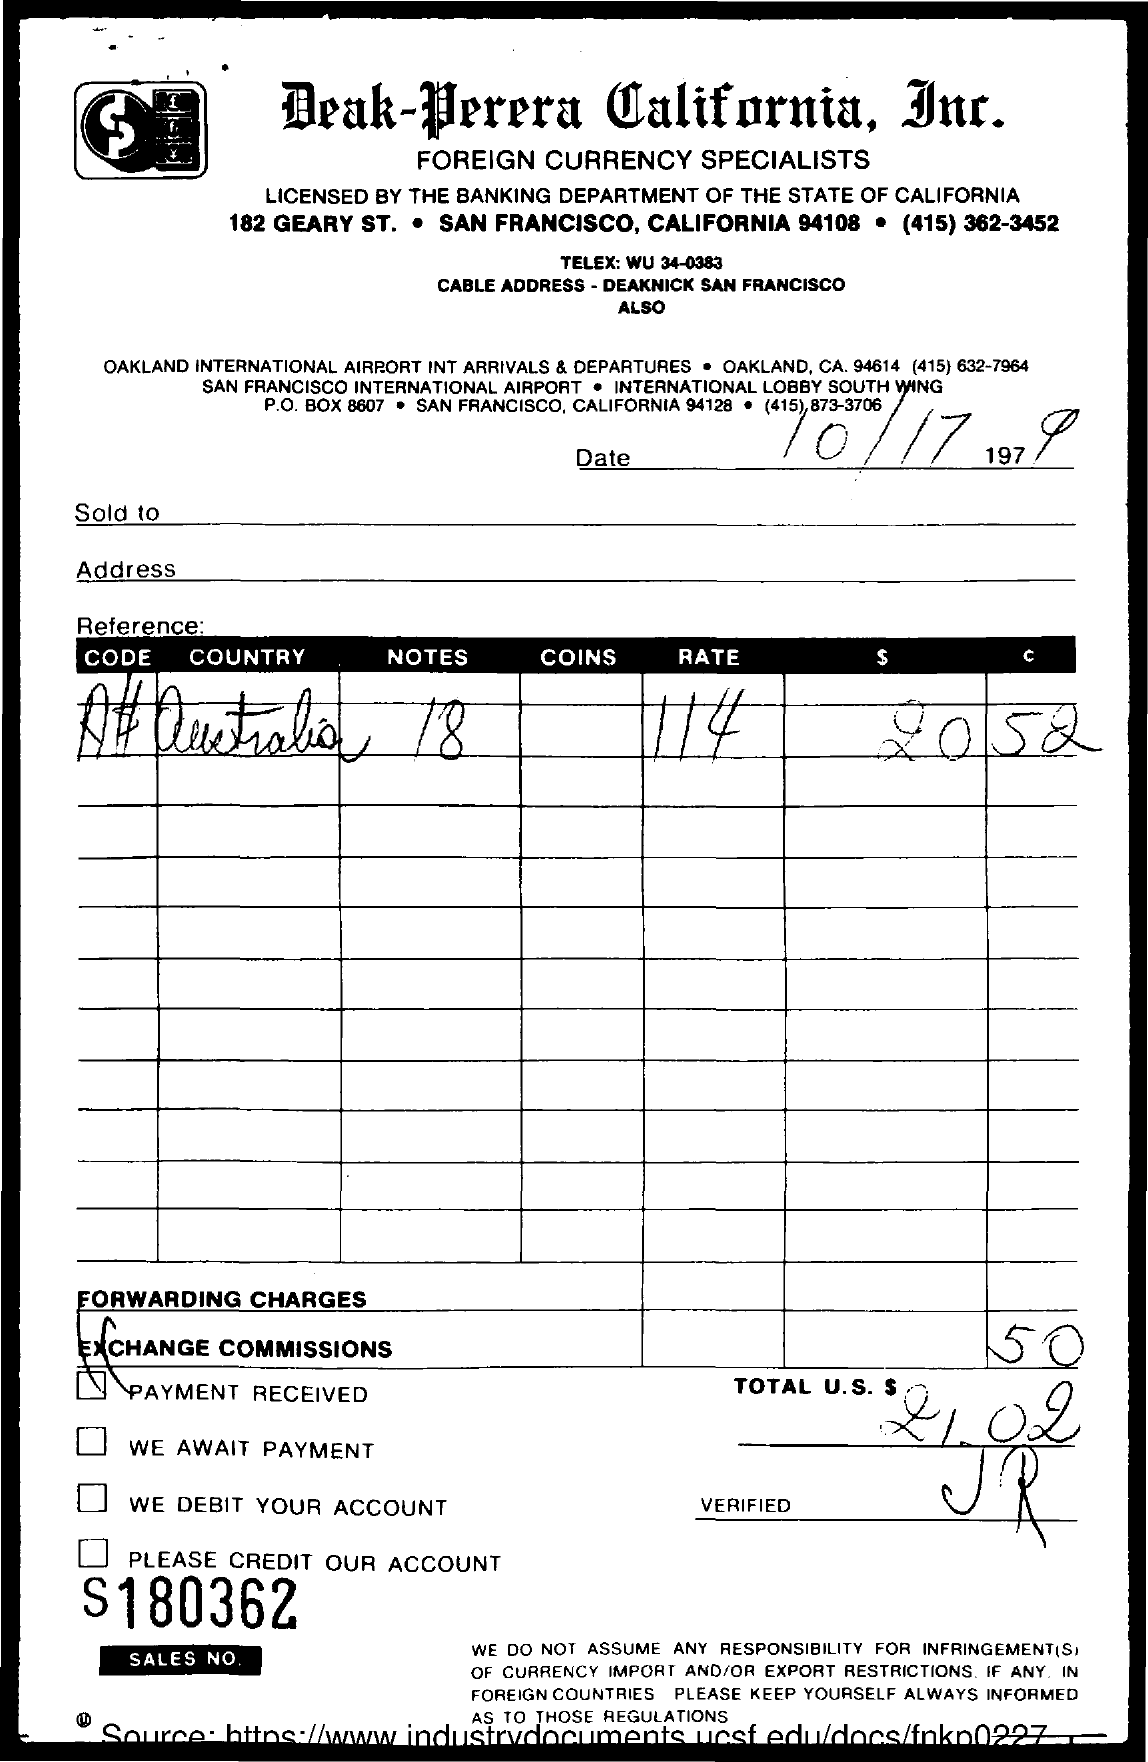Indicate a few pertinent items in this graphic. There are a total of 18 notes. The country name of the currency used in Australia is Australia. The rate is 114... The total amount in U.S dollars is 21.02. The date mentioned is October 17, 1979. 